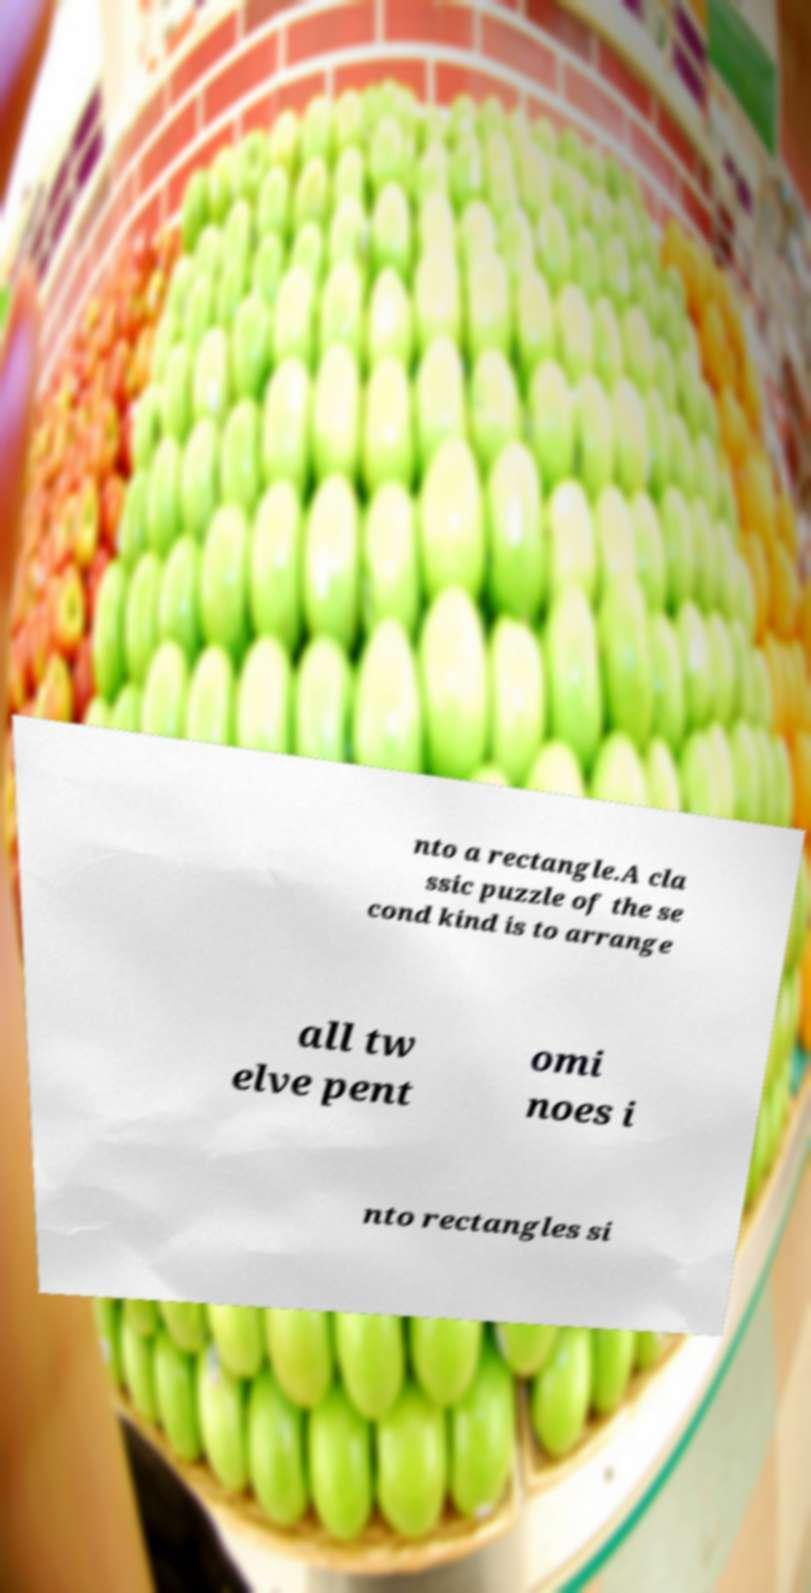Could you extract and type out the text from this image? nto a rectangle.A cla ssic puzzle of the se cond kind is to arrange all tw elve pent omi noes i nto rectangles si 